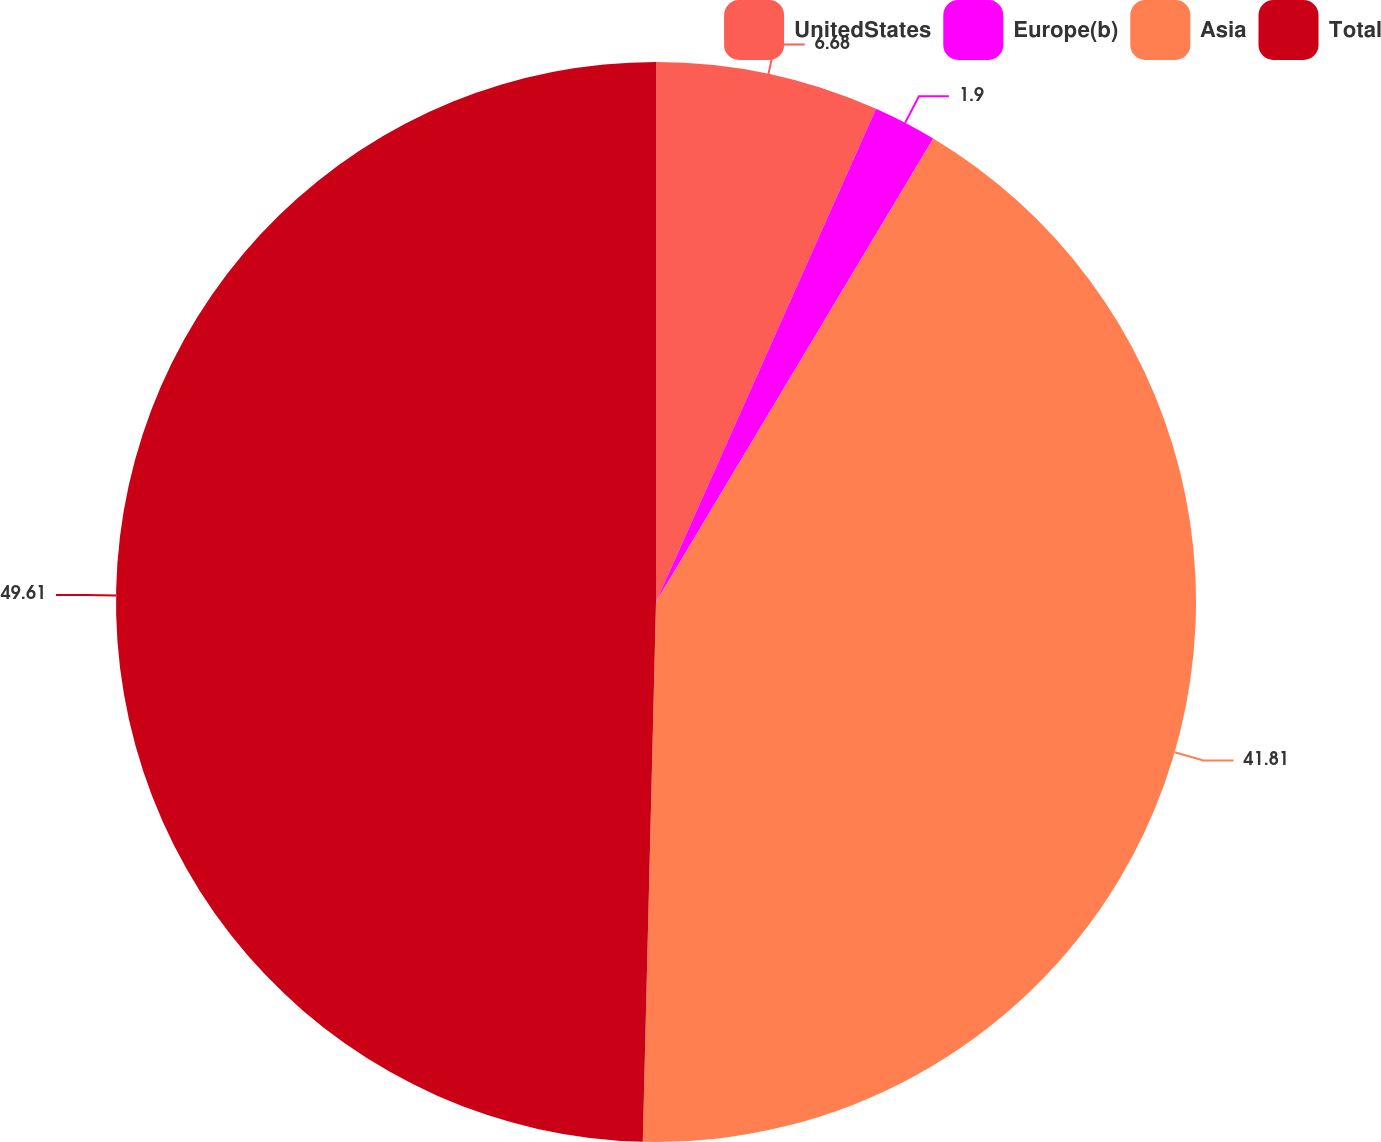Convert chart. <chart><loc_0><loc_0><loc_500><loc_500><pie_chart><fcel>UnitedStates<fcel>Europe(b)<fcel>Asia<fcel>Total<nl><fcel>6.68%<fcel>1.9%<fcel>41.81%<fcel>49.61%<nl></chart> 